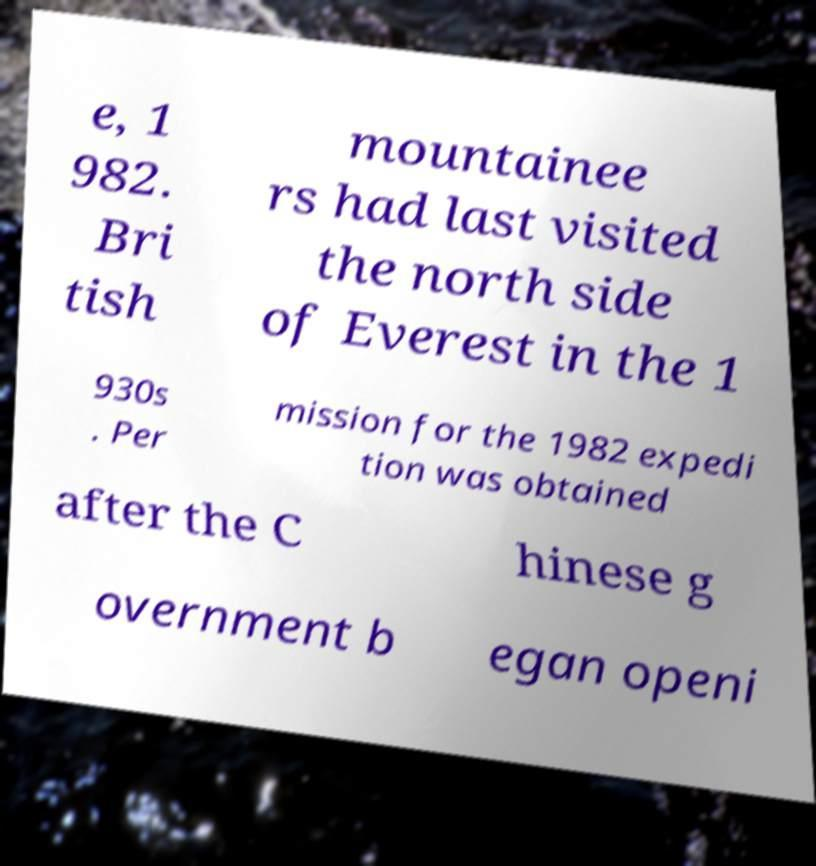Could you extract and type out the text from this image? e, 1 982. Bri tish mountainee rs had last visited the north side of Everest in the 1 930s . Per mission for the 1982 expedi tion was obtained after the C hinese g overnment b egan openi 